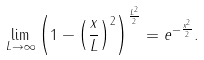Convert formula to latex. <formula><loc_0><loc_0><loc_500><loc_500>\lim _ { L \rightarrow \infty } \left ( 1 - \left ( \frac { x } { L } \right ) ^ { 2 } \right ) ^ { \frac { L ^ { 2 } } { 2 } } = e ^ { - \frac { x ^ { 2 } } { 2 } } .</formula> 